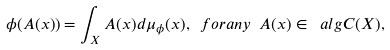<formula> <loc_0><loc_0><loc_500><loc_500>\phi ( A ( x ) ) = \int _ { X } A ( x ) d \mu _ { \phi } ( x ) , \ f o r a n y \ A ( x ) \in \ a l g { C } ( X ) ,</formula> 